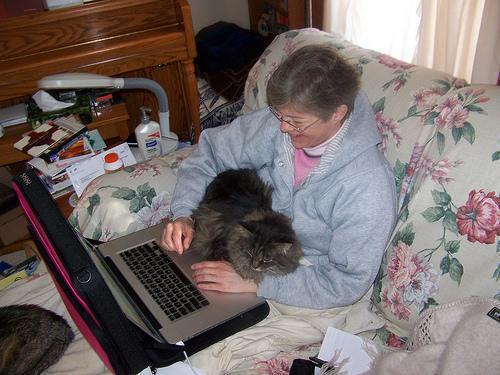How many animals are there?
Give a very brief answer. 2. How many cats are there?
Give a very brief answer. 1. 